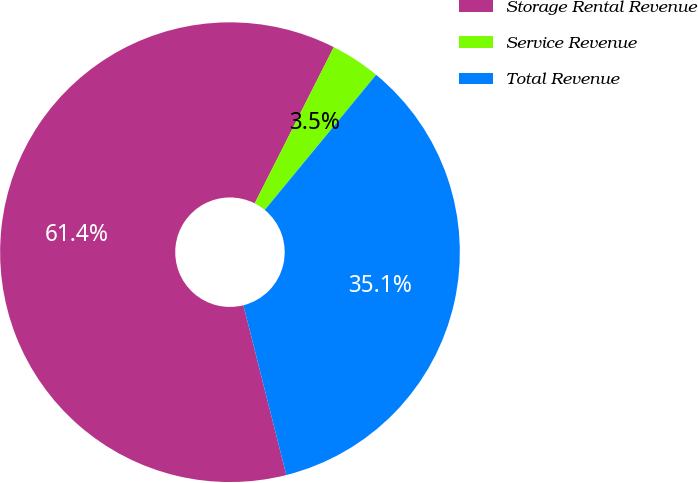Convert chart to OTSL. <chart><loc_0><loc_0><loc_500><loc_500><pie_chart><fcel>Storage Rental Revenue<fcel>Service Revenue<fcel>Total Revenue<nl><fcel>61.4%<fcel>3.51%<fcel>35.09%<nl></chart> 